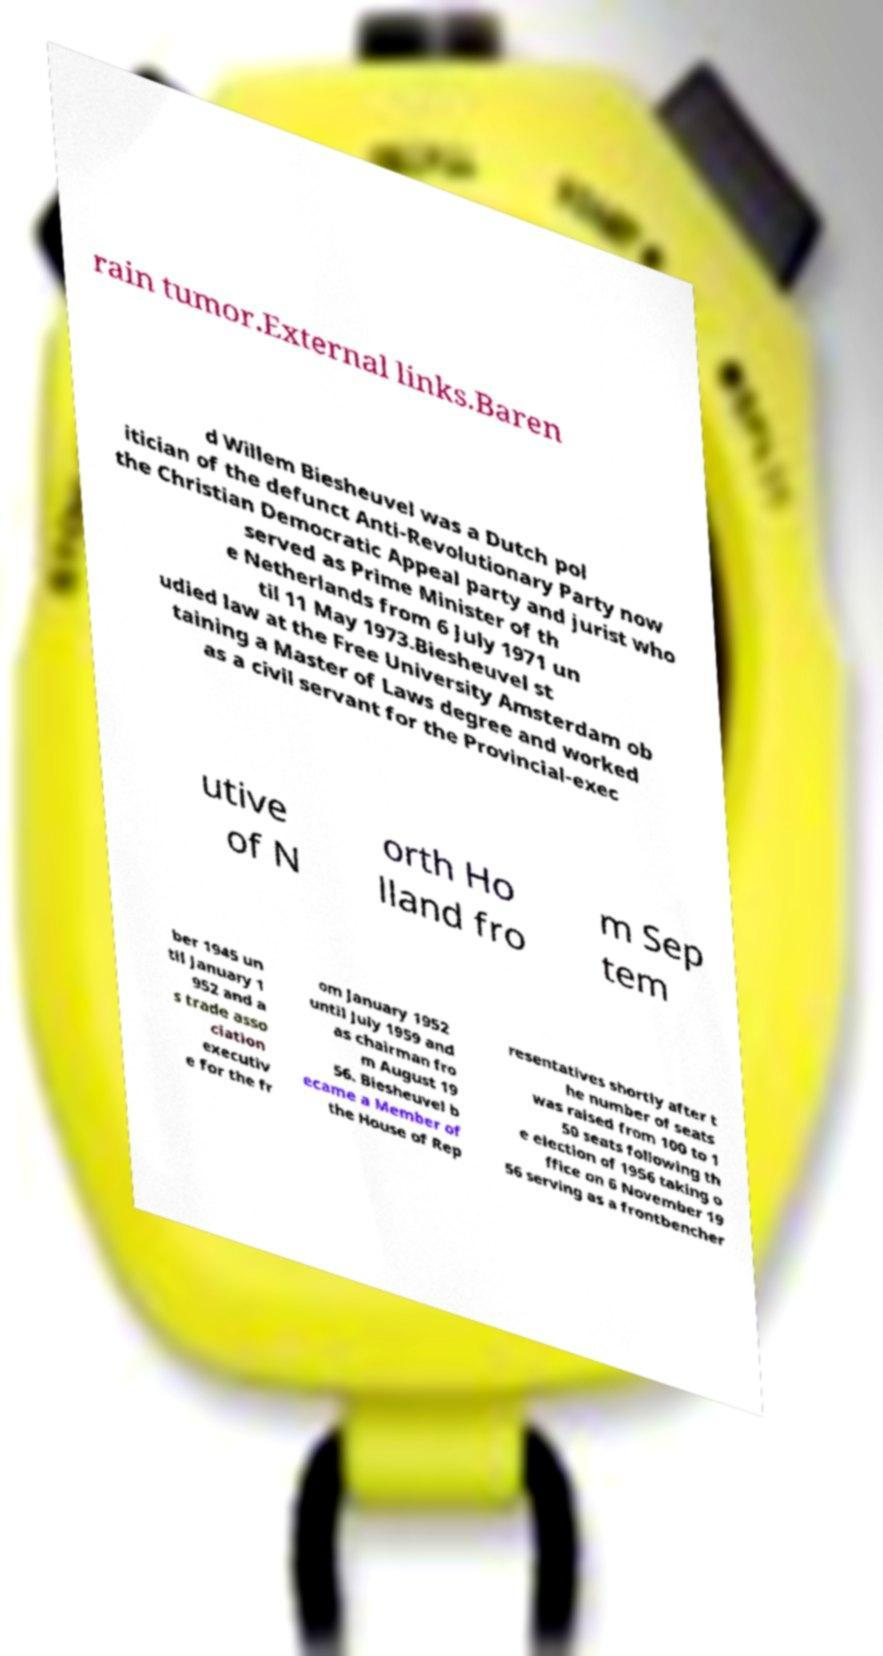Could you extract and type out the text from this image? rain tumor.External links.Baren d Willem Biesheuvel was a Dutch pol itician of the defunct Anti-Revolutionary Party now the Christian Democratic Appeal party and jurist who served as Prime Minister of th e Netherlands from 6 July 1971 un til 11 May 1973.Biesheuvel st udied law at the Free University Amsterdam ob taining a Master of Laws degree and worked as a civil servant for the Provincial-exec utive of N orth Ho lland fro m Sep tem ber 1945 un til January 1 952 and a s trade asso ciation executiv e for the fr om January 1952 until July 1959 and as chairman fro m August 19 56. Biesheuvel b ecame a Member of the House of Rep resentatives shortly after t he number of seats was raised from 100 to 1 50 seats following th e election of 1956 taking o ffice on 6 November 19 56 serving as a frontbencher 